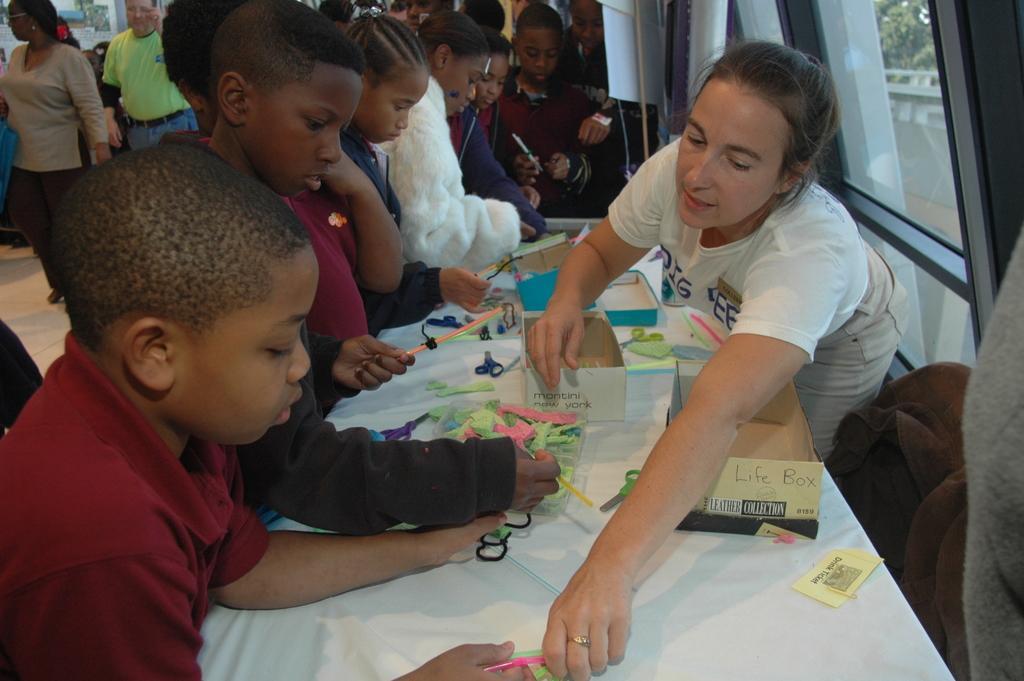In one or two sentences, can you explain what this image depicts? In the image there is a woman in white dress standing in front of window and there are few kids standing in front of table with papers,scissors and boxes on it, in the back there are many people walking. 